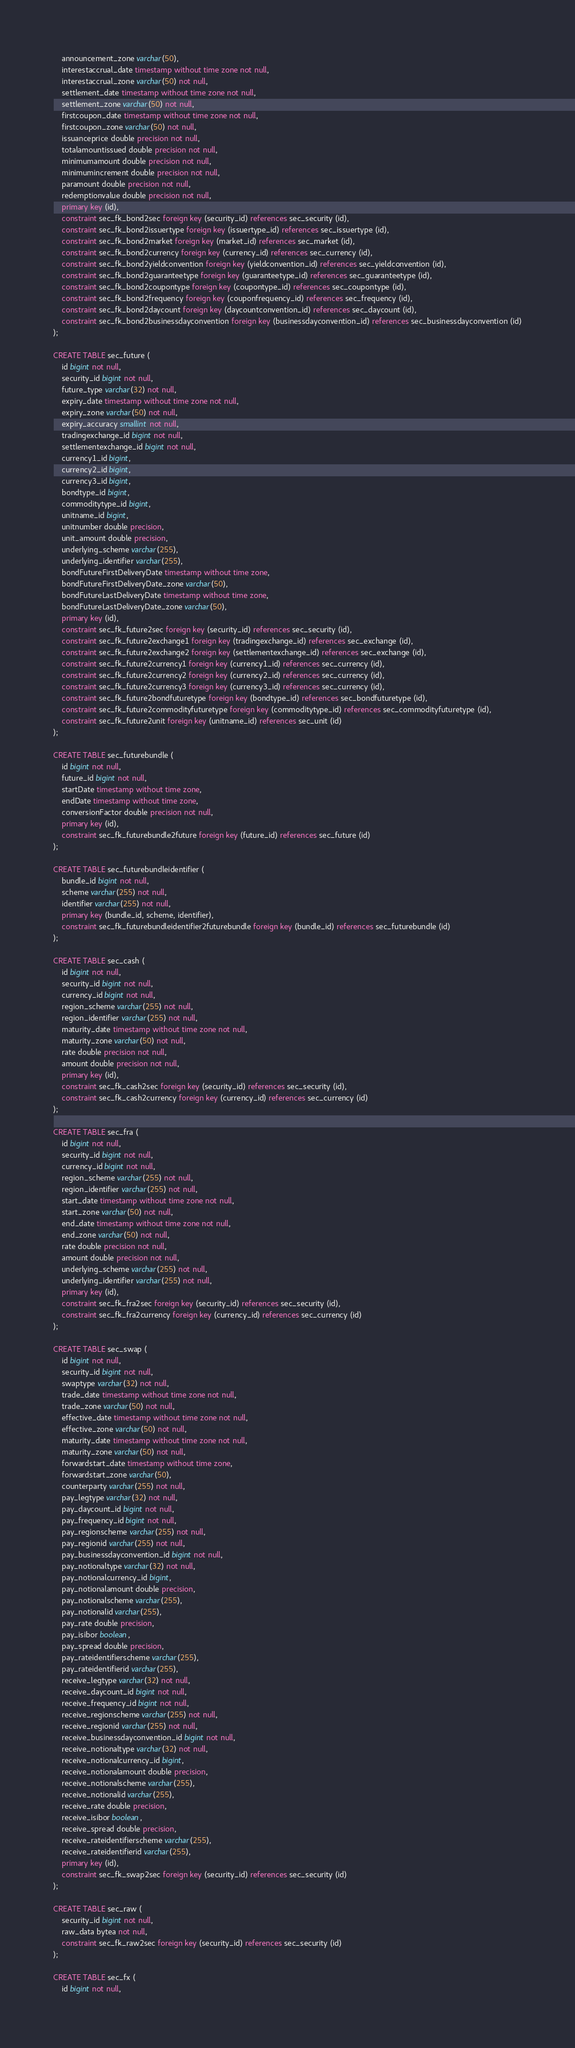Convert code to text. <code><loc_0><loc_0><loc_500><loc_500><_SQL_>    announcement_zone varchar(50),
    interestaccrual_date timestamp without time zone not null,
    interestaccrual_zone varchar(50) not null,
    settlement_date timestamp without time zone not null,
    settlement_zone varchar(50) not null,
    firstcoupon_date timestamp without time zone not null,
    firstcoupon_zone varchar(50) not null,
    issuanceprice double precision not null,
    totalamountissued double precision not null,
    minimumamount double precision not null,
    minimumincrement double precision not null,
    paramount double precision not null,
    redemptionvalue double precision not null,
    primary key (id),
    constraint sec_fk_bond2sec foreign key (security_id) references sec_security (id),
    constraint sec_fk_bond2issuertype foreign key (issuertype_id) references sec_issuertype (id),
    constraint sec_fk_bond2market foreign key (market_id) references sec_market (id),
    constraint sec_fk_bond2currency foreign key (currency_id) references sec_currency (id),
    constraint sec_fk_bond2yieldconvention foreign key (yieldconvention_id) references sec_yieldconvention (id),
    constraint sec_fk_bond2guaranteetype foreign key (guaranteetype_id) references sec_guaranteetype (id),
    constraint sec_fk_bond2coupontype foreign key (coupontype_id) references sec_coupontype (id),
    constraint sec_fk_bond2frequency foreign key (couponfrequency_id) references sec_frequency (id),
    constraint sec_fk_bond2daycount foreign key (daycountconvention_id) references sec_daycount (id),
    constraint sec_fk_bond2businessdayconvention foreign key (businessdayconvention_id) references sec_businessdayconvention (id)
);

CREATE TABLE sec_future (
    id bigint not null,
    security_id bigint not null,
    future_type varchar(32) not null,
    expiry_date timestamp without time zone not null,
    expiry_zone varchar(50) not null,
    expiry_accuracy smallint not null,
    tradingexchange_id bigint not null,
    settlementexchange_id bigint not null,
    currency1_id bigint,
    currency2_id bigint,
    currency3_id bigint,
    bondtype_id bigint,
    commoditytype_id bigint,
    unitname_id bigint,
    unitnumber double precision,
    unit_amount double precision,
    underlying_scheme varchar(255),
    underlying_identifier varchar(255), 
    bondFutureFirstDeliveryDate timestamp without time zone,
    bondFutureFirstDeliveryDate_zone varchar(50),
    bondFutureLastDeliveryDate timestamp without time zone,
    bondFutureLastDeliveryDate_zone varchar(50),
    primary key (id),
    constraint sec_fk_future2sec foreign key (security_id) references sec_security (id),
    constraint sec_fk_future2exchange1 foreign key (tradingexchange_id) references sec_exchange (id),
    constraint sec_fk_future2exchange2 foreign key (settlementexchange_id) references sec_exchange (id),
    constraint sec_fk_future2currency1 foreign key (currency1_id) references sec_currency (id),
    constraint sec_fk_future2currency2 foreign key (currency2_id) references sec_currency (id),
    constraint sec_fk_future2currency3 foreign key (currency3_id) references sec_currency (id),
    constraint sec_fk_future2bondfuturetype foreign key (bondtype_id) references sec_bondfuturetype (id),
    constraint sec_fk_future2commodityfuturetype foreign key (commoditytype_id) references sec_commodityfuturetype (id),
    constraint sec_fk_future2unit foreign key (unitname_id) references sec_unit (id)
);

CREATE TABLE sec_futurebundle (
    id bigint not null,
    future_id bigint not null,
    startDate timestamp without time zone,
    endDate timestamp without time zone,
    conversionFactor double precision not null,
    primary key (id),
    constraint sec_fk_futurebundle2future foreign key (future_id) references sec_future (id)
);

CREATE TABLE sec_futurebundleidentifier (
    bundle_id bigint not null,
    scheme varchar(255) not null,
    identifier varchar(255) not null,
    primary key (bundle_id, scheme, identifier),
    constraint sec_fk_futurebundleidentifier2futurebundle foreign key (bundle_id) references sec_futurebundle (id)
);

CREATE TABLE sec_cash (
    id bigint not null,
    security_id bigint not null,
    currency_id bigint not null,
    region_scheme varchar(255) not null,
    region_identifier varchar(255) not null,
    maturity_date timestamp without time zone not null,
    maturity_zone varchar(50) not null,
    rate double precision not null,
    amount double precision not null,
    primary key (id),
    constraint sec_fk_cash2sec foreign key (security_id) references sec_security (id),
    constraint sec_fk_cash2currency foreign key (currency_id) references sec_currency (id)
);

CREATE TABLE sec_fra (
    id bigint not null,
    security_id bigint not null,
    currency_id bigint not null,
    region_scheme varchar(255) not null,
    region_identifier varchar(255) not null,
    start_date timestamp without time zone not null,
    start_zone varchar(50) not null,
    end_date timestamp without time zone not null,
    end_zone varchar(50) not null,
    rate double precision not null,
    amount double precision not null,
    underlying_scheme varchar(255) not null,
    underlying_identifier varchar(255) not null,
    primary key (id),
    constraint sec_fk_fra2sec foreign key (security_id) references sec_security (id),
    constraint sec_fk_fra2currency foreign key (currency_id) references sec_currency (id)
);

CREATE TABLE sec_swap (
    id bigint not null,
    security_id bigint not null,
    swaptype varchar(32) not null,
    trade_date timestamp without time zone not null,
    trade_zone varchar(50) not null,
    effective_date timestamp without time zone not null,
    effective_zone varchar(50) not null,
    maturity_date timestamp without time zone not null,
    maturity_zone varchar(50) not null,
    forwardstart_date timestamp without time zone,
    forwardstart_zone varchar(50),
    counterparty varchar(255) not null,
    pay_legtype varchar(32) not null,
    pay_daycount_id bigint not null,
    pay_frequency_id bigint not null,
    pay_regionscheme varchar(255) not null,
    pay_regionid varchar(255) not null,
    pay_businessdayconvention_id bigint not null,
    pay_notionaltype varchar(32) not null,
    pay_notionalcurrency_id bigint,
    pay_notionalamount double precision,
    pay_notionalscheme varchar(255),
    pay_notionalid varchar(255),
    pay_rate double precision,
    pay_isibor boolean,
    pay_spread double precision,
    pay_rateidentifierscheme varchar(255),
    pay_rateidentifierid varchar(255),
    receive_legtype varchar(32) not null,
    receive_daycount_id bigint not null,
    receive_frequency_id bigint not null,
    receive_regionscheme varchar(255) not null,
    receive_regionid varchar(255) not null,
    receive_businessdayconvention_id bigint not null,
    receive_notionaltype varchar(32) not null,
    receive_notionalcurrency_id bigint,
    receive_notionalamount double precision,
    receive_notionalscheme varchar(255),
    receive_notionalid varchar(255),
    receive_rate double precision,
    receive_isibor boolean,
    receive_spread double precision,
    receive_rateidentifierscheme varchar(255),
    receive_rateidentifierid varchar(255),
    primary key (id),
    constraint sec_fk_swap2sec foreign key (security_id) references sec_security (id)
);

CREATE TABLE sec_raw (
    security_id bigint not null,
    raw_data bytea not null,
    constraint sec_fk_raw2sec foreign key (security_id) references sec_security (id)
);

CREATE TABLE sec_fx (
    id bigint not null,</code> 